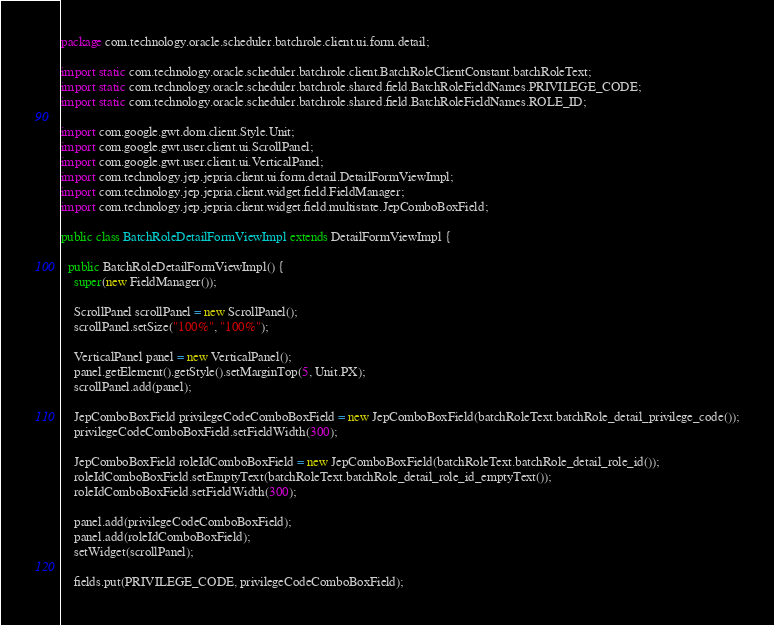<code> <loc_0><loc_0><loc_500><loc_500><_Java_>package com.technology.oracle.scheduler.batchrole.client.ui.form.detail;
 
import static com.technology.oracle.scheduler.batchrole.client.BatchRoleClientConstant.batchRoleText;
import static com.technology.oracle.scheduler.batchrole.shared.field.BatchRoleFieldNames.PRIVILEGE_CODE;
import static com.technology.oracle.scheduler.batchrole.shared.field.BatchRoleFieldNames.ROLE_ID;

import com.google.gwt.dom.client.Style.Unit;
import com.google.gwt.user.client.ui.ScrollPanel;
import com.google.gwt.user.client.ui.VerticalPanel;
import com.technology.jep.jepria.client.ui.form.detail.DetailFormViewImpl;
import com.technology.jep.jepria.client.widget.field.FieldManager;
import com.technology.jep.jepria.client.widget.field.multistate.JepComboBoxField;
 
public class BatchRoleDetailFormViewImpl extends DetailFormViewImpl {  
 
  public BatchRoleDetailFormViewImpl() {
    super(new FieldManager());

    ScrollPanel scrollPanel = new ScrollPanel();
    scrollPanel.setSize("100%", "100%");
    
    VerticalPanel panel = new VerticalPanel();
    panel.getElement().getStyle().setMarginTop(5, Unit.PX);
    scrollPanel.add(panel);
    
    JepComboBoxField privilegeCodeComboBoxField = new JepComboBoxField(batchRoleText.batchRole_detail_privilege_code());
    privilegeCodeComboBoxField.setFieldWidth(300);
    
    JepComboBoxField roleIdComboBoxField = new JepComboBoxField(batchRoleText.batchRole_detail_role_id());
    roleIdComboBoxField.setEmptyText(batchRoleText.batchRole_detail_role_id_emptyText());
    roleIdComboBoxField.setFieldWidth(300);
    
    panel.add(privilegeCodeComboBoxField);
    panel.add(roleIdComboBoxField);
    setWidget(scrollPanel);
 
    fields.put(PRIVILEGE_CODE, privilegeCodeComboBoxField);</code> 